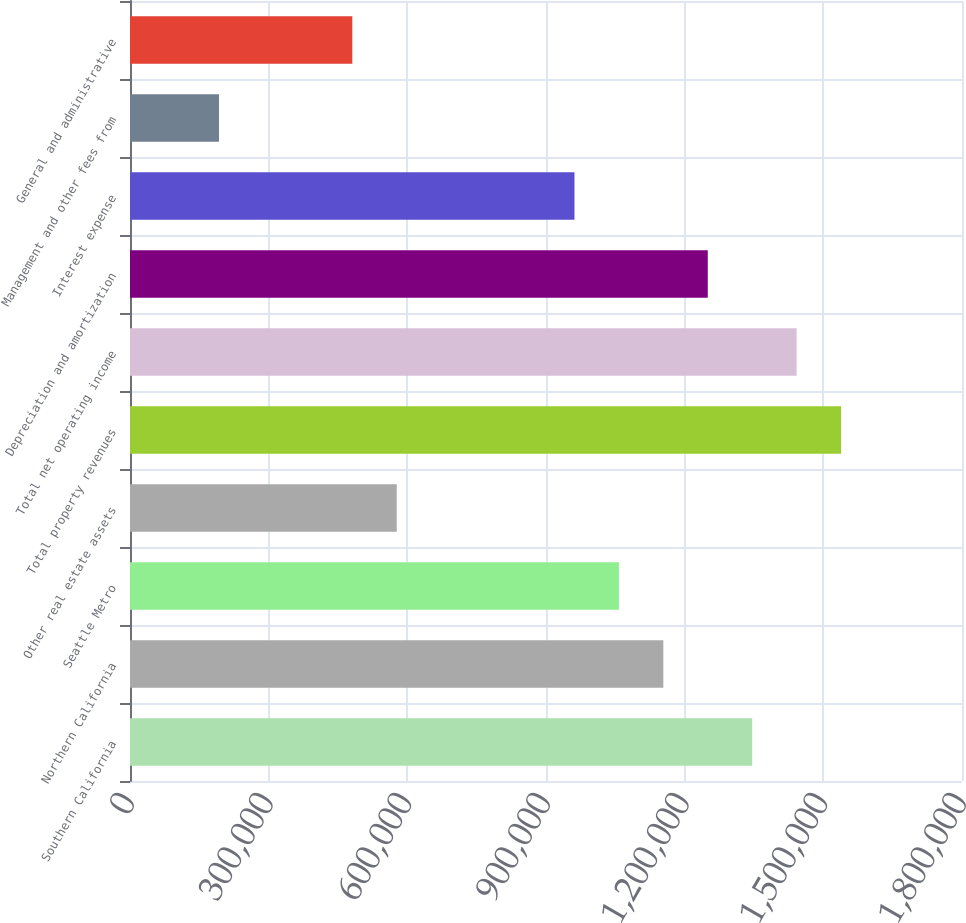<chart> <loc_0><loc_0><loc_500><loc_500><bar_chart><fcel>Southern California<fcel>Northern California<fcel>Seattle Metro<fcel>Other real estate assets<fcel>Total property revenues<fcel>Total net operating income<fcel>Depreciation and amortization<fcel>Interest expense<fcel>Management and other fees from<fcel>General and administrative<nl><fcel>1.34612e+06<fcel>1.15386e+06<fcel>1.05772e+06<fcel>577062<fcel>1.53838e+06<fcel>1.44225e+06<fcel>1.24999e+06<fcel>961591<fcel>192533<fcel>480930<nl></chart> 